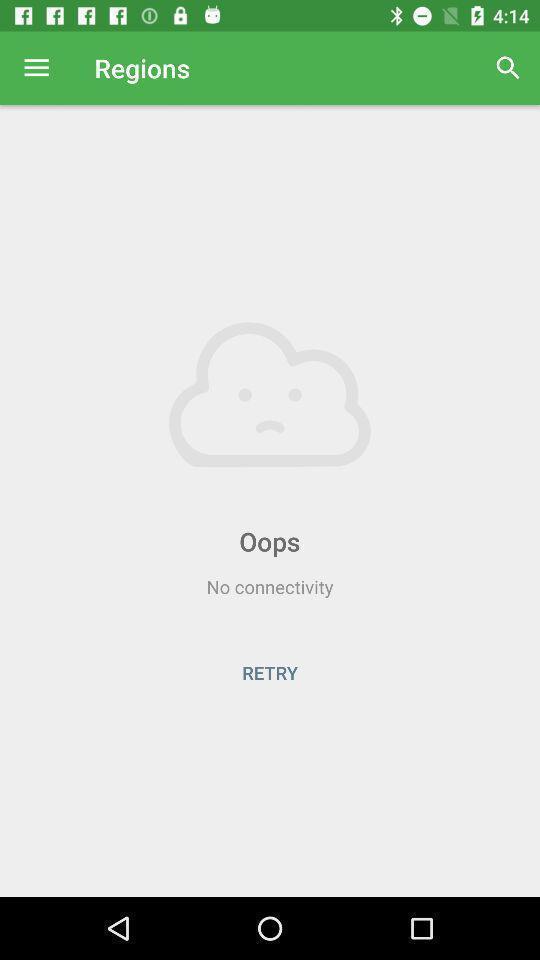Summarize the main components in this picture. Page displaying the network connectivity. 